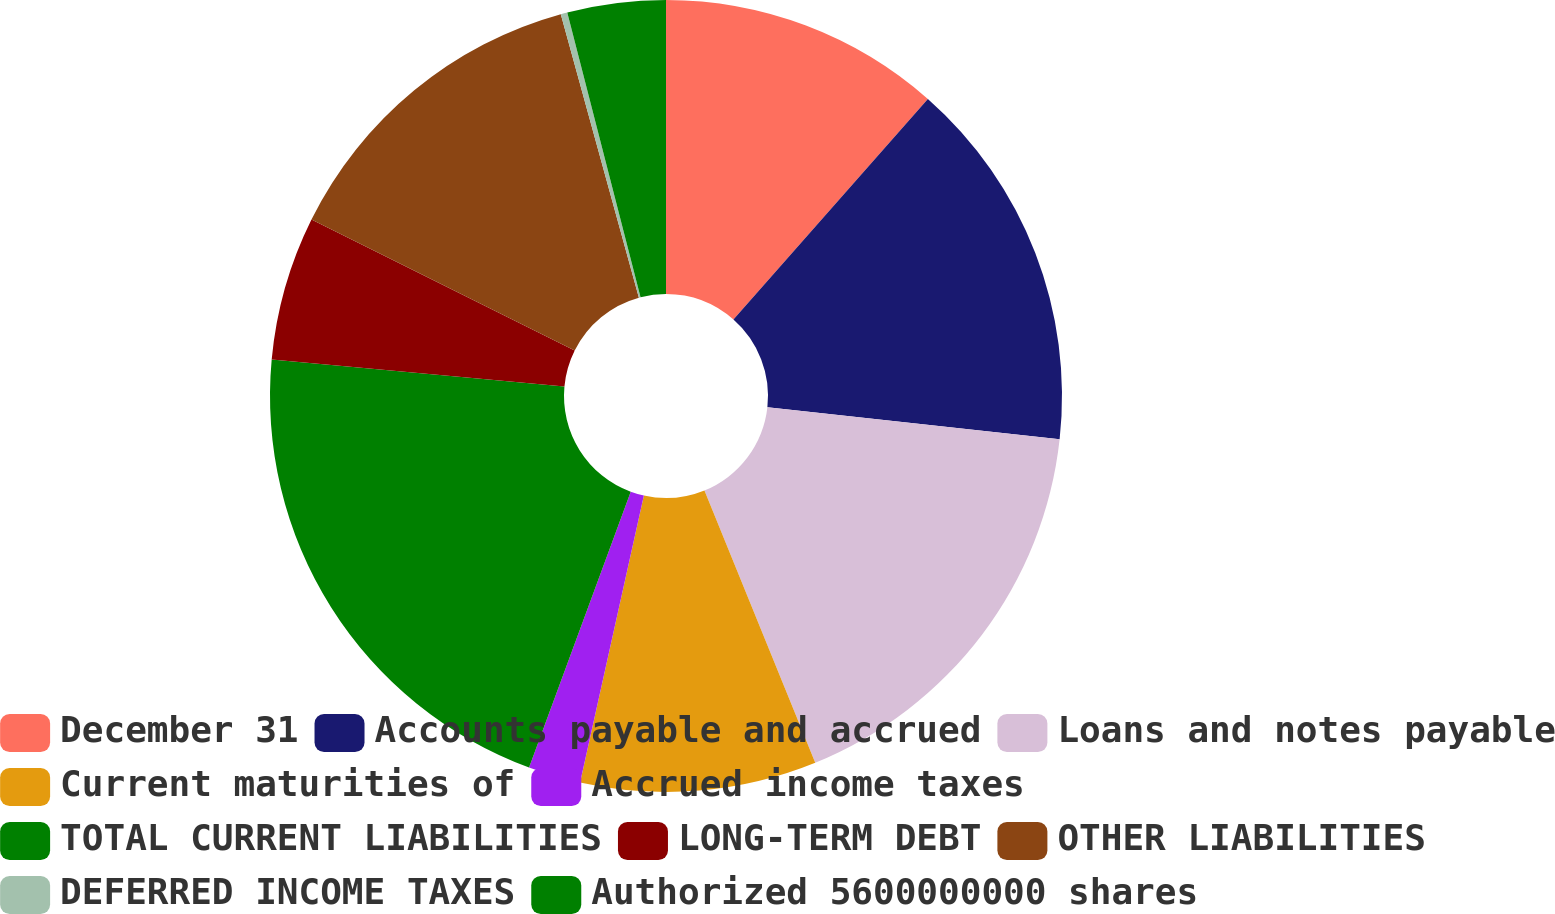<chart> <loc_0><loc_0><loc_500><loc_500><pie_chart><fcel>December 31<fcel>Accounts payable and accrued<fcel>Loans and notes payable<fcel>Current maturities of<fcel>Accrued income taxes<fcel>TOTAL CURRENT LIABILITIES<fcel>LONG-TERM DEBT<fcel>OTHER LIABILITIES<fcel>DEFERRED INCOME TAXES<fcel>Authorized 5600000000 shares<nl><fcel>11.5%<fcel>15.24%<fcel>17.11%<fcel>9.63%<fcel>2.14%<fcel>20.85%<fcel>5.88%<fcel>13.37%<fcel>0.27%<fcel>4.01%<nl></chart> 